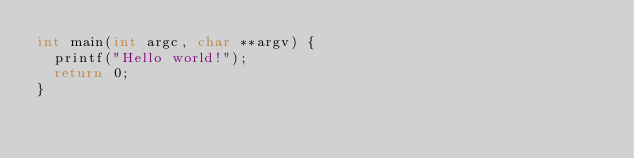<code> <loc_0><loc_0><loc_500><loc_500><_C_>int main(int argc, char **argv) {
  printf("Hello world!");
  return 0;
}</code> 